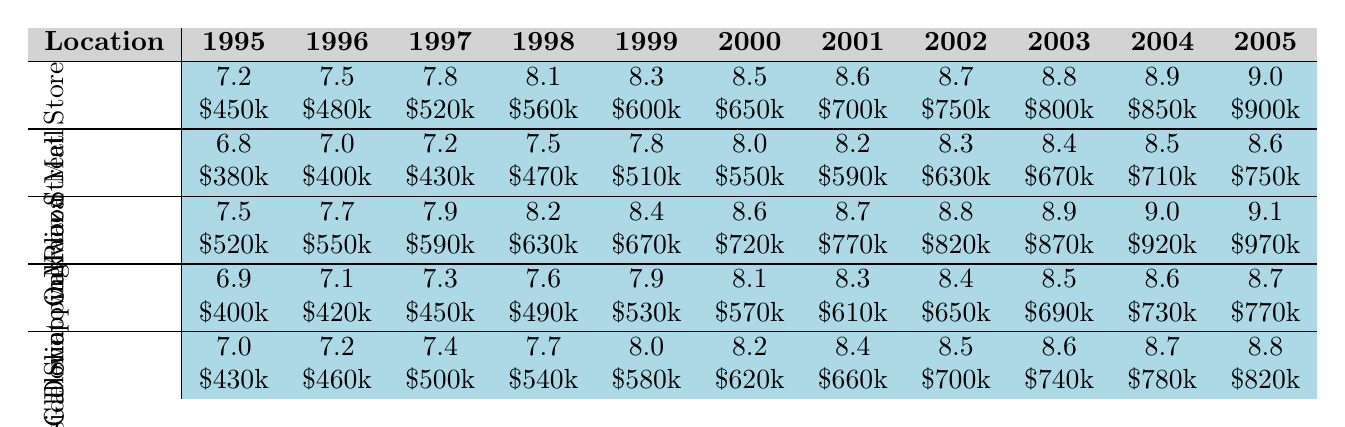What was the customer satisfaction score for Downtown Plaza in 2001? The table shows that the customer satisfaction score for Downtown Plaza in 2001 is 8.7.
Answer: 8.7 What were the sales figures for the Oakwood Mall in 1998? According to the table, the sales figures for Oakwood Mall in 1998 were \$470,000.
Answer: \$470,000 Which store had the highest customer satisfaction score in 2005? The table shows that in 2005, the Downtown Plaza had the highest score of 9.1.
Answer: Downtown Plaza What were the average customer satisfaction scores for the Westfield Galleria across the years? The scores for Westfield Galleria are 7.0, 7.2, 7.4, 7.7, 8.0, 8.2, 8.4, 8.5, 8.6, 8.7, and 8.8. Adding these scores gives 89.5 and dividing by 11 results in an average of approximately 8.14.
Answer: 8.14 Were the sales figures for Riverside Shopping Center in 2000 above or below \$550,000? The table indicates that the sales figure for Riverside Shopping Center in 2000 was \$570,000, which is above \$550,000.
Answer: Yes What is the difference in customer satisfaction scores between Main Street Store and Oakwood Mall in 2004? The customer satisfaction score for Main Street Store in 2004 is 8.9, and for Oakwood Mall, it is 8.5. The difference is 8.9 - 8.5 = 0.4.
Answer: 0.4 If you compare the total sales figures of Downtown Plaza from 1995 to 2005, how much did the sales increase? The sales figures for Downtown Plaza from 1995 to 2005 are \$520,000 and \$970,000 respectively. The increase is \$970,000 - \$520,000 = \$450,000.
Answer: \$450,000 Which store had the lowest customer satisfaction score in 1996? By checking the table, the lowest score in 1996 is 7.0 from Oakwood Mall.
Answer: Oakwood Mall What was the trend of customer satisfaction scores for Main Street Store from 1995 to 2005? Analyzing the scores in the table, the trend shows a consistent increase from 7.2 in 1995 to 9.0 in 2005.
Answer: Consistent increase What is the median of customer satisfaction scores for all locations in 2003? The customer satisfaction scores for 2003 are 8.8, 8.4, 8.9, 8.5, and 8.6. Arranging them gives 8.4, 8.5, 8.6, 8.8, 8.9. The median is the middle value, which is 8.6.
Answer: 8.6 If you average the sales figures from 1995 to 2005 for the Oakwood Mall, what do you get? The sales figures for Oakwood Mall are \$380,000, \$400,000, \$430,000, \$470,000, \$510,000, \$550,000, \$590,000, \$630,000, \$670,000, \$710,000, and \$750,000. Summing these gives \$6,300,000. Dividing by 11 gives an average of approximately \$572,727.
Answer: \$572,727 